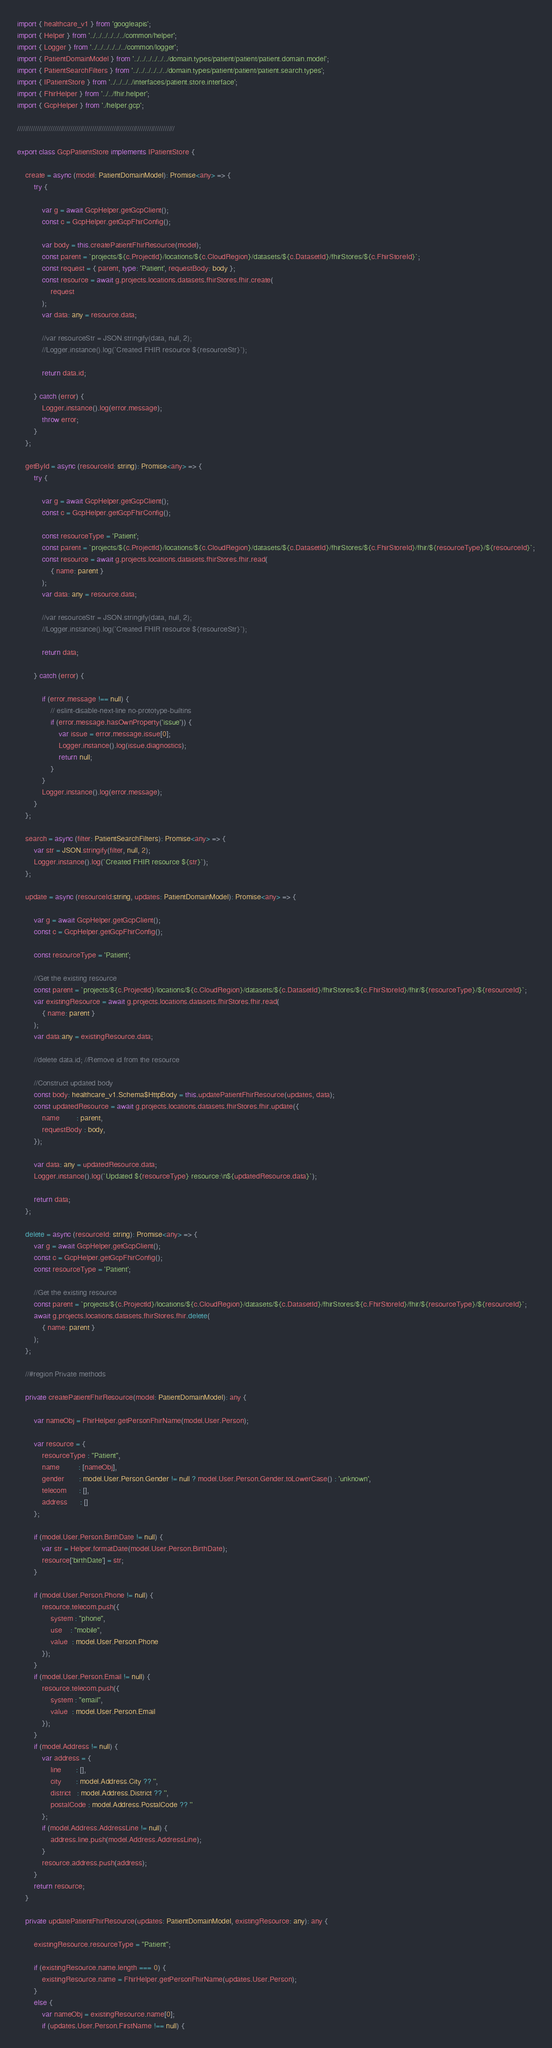Convert code to text. <code><loc_0><loc_0><loc_500><loc_500><_TypeScript_>import { healthcare_v1 } from 'googleapis';
import { Helper } from '../../../../../../common/helper';
import { Logger } from '../../../../../../common/logger';
import { PatientDomainModel } from '../../../../../../domain.types/patient/patient/patient.domain.model';
import { PatientSearchFilters } from '../../../../../../domain.types/patient/patient/patient.search.types';
import { IPatientStore } from '../../../../interfaces/patient.store.interface';
import { FhirHelper } from '../../fhir.helper';
import { GcpHelper } from './helper.gcp';

////////////////////////////////////////////////////////////////////////////////

export class GcpPatientStore implements IPatientStore {

    create = async (model: PatientDomainModel): Promise<any> => {
        try {

            var g = await GcpHelper.getGcpClient();
            const c = GcpHelper.getGcpFhirConfig();

            var body = this.createPatientFhirResource(model);
            const parent = `projects/${c.ProjectId}/locations/${c.CloudRegion}/datasets/${c.DatasetId}/fhirStores/${c.FhirStoreId}`;
            const request = { parent, type: 'Patient', requestBody: body };
            const resource = await g.projects.locations.datasets.fhirStores.fhir.create(
                request
            );
            var data: any = resource.data;

            //var resourceStr = JSON.stringify(data, null, 2);
            //Logger.instance().log(`Created FHIR resource ${resourceStr}`);

            return data.id;

        } catch (error) {
            Logger.instance().log(error.message);
            throw error;
        }
    };

    getById = async (resourceId: string): Promise<any> => {
        try {

            var g = await GcpHelper.getGcpClient();
            const c = GcpHelper.getGcpFhirConfig();

            const resourceType = 'Patient';
            const parent = `projects/${c.ProjectId}/locations/${c.CloudRegion}/datasets/${c.DatasetId}/fhirStores/${c.FhirStoreId}/fhir/${resourceType}/${resourceId}`;
            const resource = await g.projects.locations.datasets.fhirStores.fhir.read(
                { name: parent }
            );
            var data: any = resource.data;

            //var resourceStr = JSON.stringify(data, null, 2);
            //Logger.instance().log(`Created FHIR resource ${resourceStr}`);

            return data;

        } catch (error) {

            if (error.message !== null) {
                // eslint-disable-next-line no-prototype-builtins
                if (error.message.hasOwnProperty('issue')) {
                    var issue = error.message.issue[0];
                    Logger.instance().log(issue.diagnostics);
                    return null;
                }
            }
            Logger.instance().log(error.message);
        }
    };
    
    search = async (filter: PatientSearchFilters): Promise<any> => {
        var str = JSON.stringify(filter, null, 2);
        Logger.instance().log(`Created FHIR resource ${str}`);
    };

    update = async (resourceId:string, updates: PatientDomainModel): Promise<any> => {

        var g = await GcpHelper.getGcpClient();
        const c = GcpHelper.getGcpFhirConfig();

        const resourceType = 'Patient';

        //Get the existing resource
        const parent = `projects/${c.ProjectId}/locations/${c.CloudRegion}/datasets/${c.DatasetId}/fhirStores/${c.FhirStoreId}/fhir/${resourceType}/${resourceId}`;
        var existingResource = await g.projects.locations.datasets.fhirStores.fhir.read(
            { name: parent }
        );
        var data:any = existingResource.data;

        //delete data.id; //Remove id from the resource
        
        //Construct updated body
        const body: healthcare_v1.Schema$HttpBody = this.updatePatientFhirResource(updates, data);
        const updatedResource = await g.projects.locations.datasets.fhirStores.fhir.update({
            name        : parent,
            requestBody : body,
        });
        
        var data: any = updatedResource.data;
        Logger.instance().log(`Updated ${resourceType} resource:\n${updatedResource.data}`);

        return data;
    };

    delete = async (resourceId: string): Promise<any> => {
        var g = await GcpHelper.getGcpClient();
        const c = GcpHelper.getGcpFhirConfig();
        const resourceType = 'Patient';

        //Get the existing resource
        const parent = `projects/${c.ProjectId}/locations/${c.CloudRegion}/datasets/${c.DatasetId}/fhirStores/${c.FhirStoreId}/fhir/${resourceType}/${resourceId}`;
        await g.projects.locations.datasets.fhirStores.fhir.delete(
            { name: parent }
        );
    };

    //#region Private methods

    private createPatientFhirResource(model: PatientDomainModel): any {

        var nameObj = FhirHelper.getPersonFhirName(model.User.Person);

        var resource = {
            resourceType : "Patient",
            name         : [nameObj],
            gender       : model.User.Person.Gender != null ? model.User.Person.Gender.toLowerCase() : 'unknown',
            telecom      : [],
            address      : []
        };
        
        if (model.User.Person.BirthDate != null) {
            var str = Helper.formatDate(model.User.Person.BirthDate);
            resource['birthDate'] = str;
        }

        if (model.User.Person.Phone != null) {
            resource.telecom.push({
                system : "phone",
                use    : "mobile",
                value  : model.User.Person.Phone
            });
        }
        if (model.User.Person.Email != null) {
            resource.telecom.push({
                system : "email",
                value  : model.User.Person.Email
            });
        }
        if (model.Address != null) {
            var address = {
                line       : [],
                city       : model.Address.City ?? '',
                district   : model.Address.District ?? '',
                postalCode : model.Address.PostalCode ?? ''
            };
            if (model.Address.AddressLine != null) {
                address.line.push(model.Address.AddressLine);
            }
            resource.address.push(address);
        }
        return resource;
    }

    private updatePatientFhirResource(updates: PatientDomainModel, existingResource: any): any {

        existingResource.resourceType = "Patient";

        if (existingResource.name.length === 0) {
            existingResource.name = FhirHelper.getPersonFhirName(updates.User.Person);
        }
        else {
            var nameObj = existingResource.name[0];
            if (updates.User.Person.FirstName !== null) {</code> 